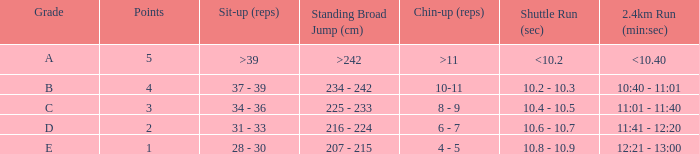Tell me the 2.4km run for points less than 2 12:21 - 13:00. 